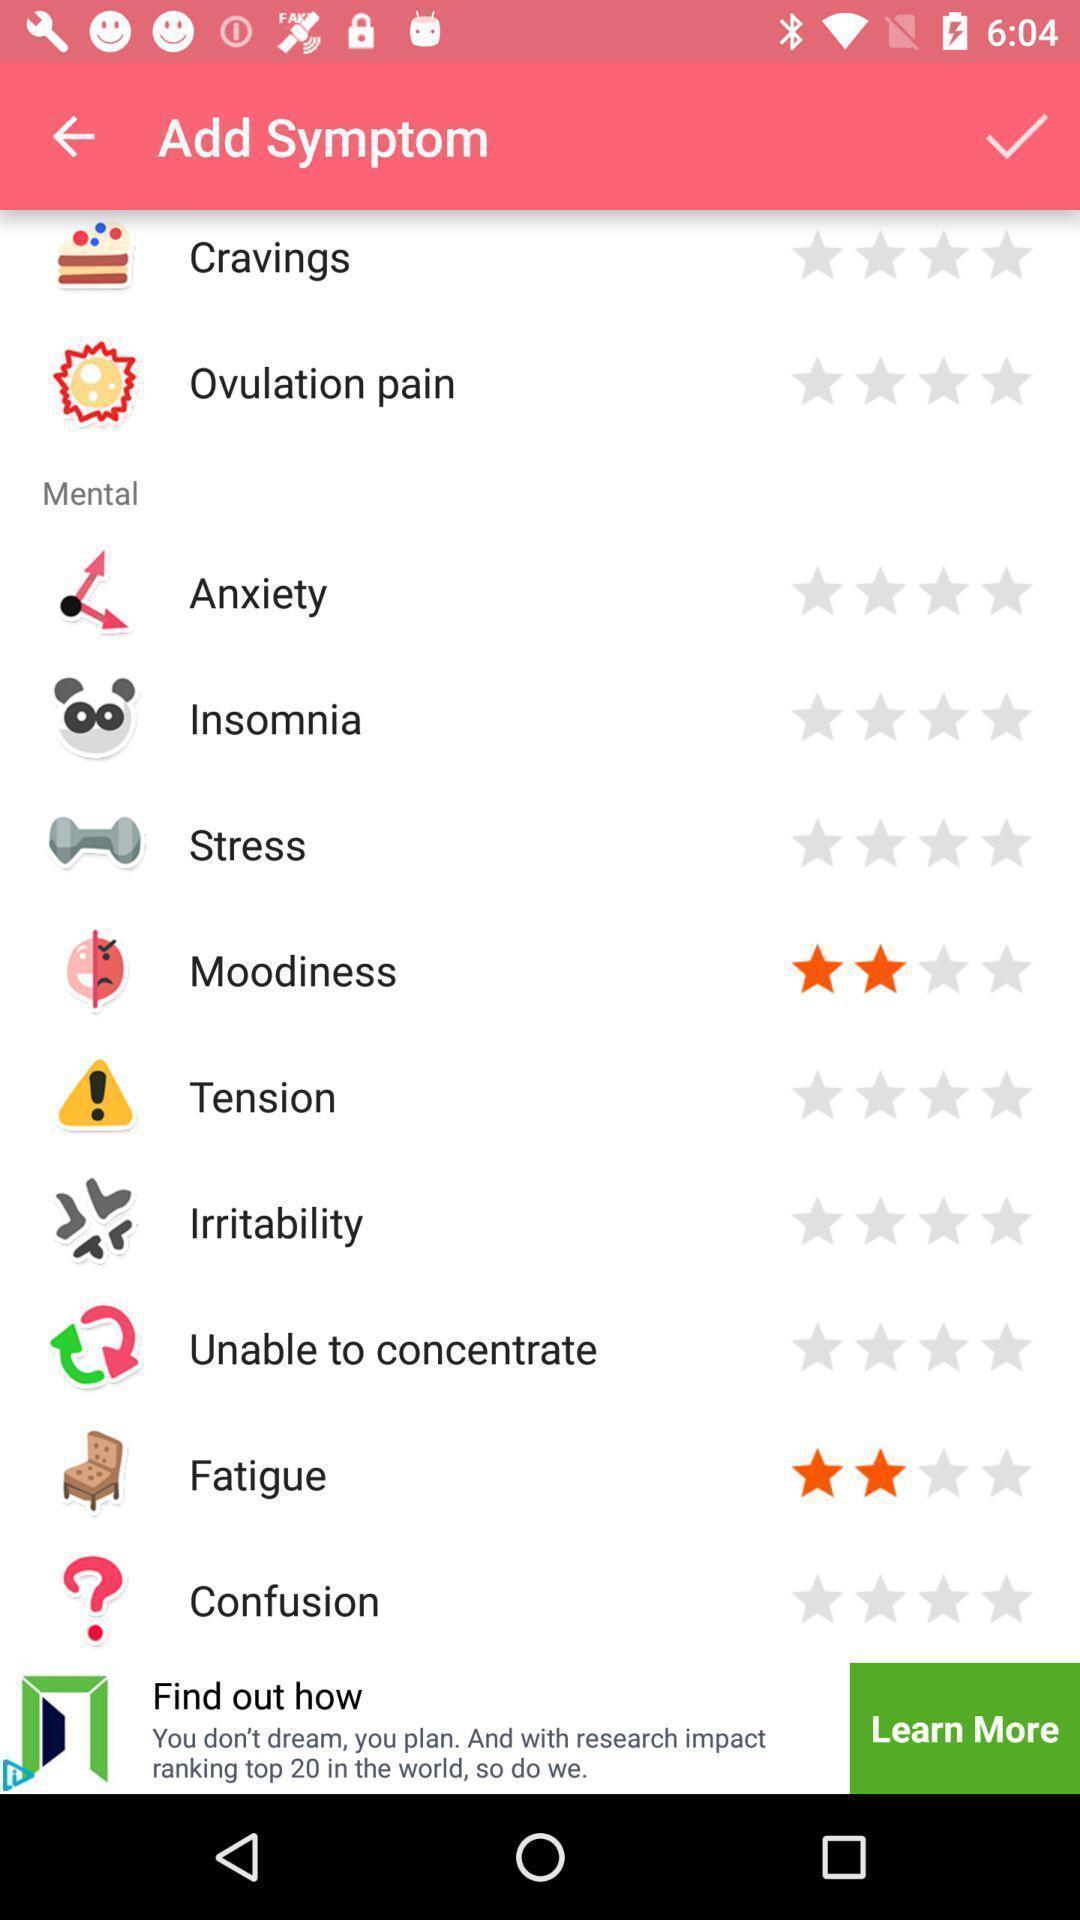Describe this image in words. Screen showing list of options with ratings. 